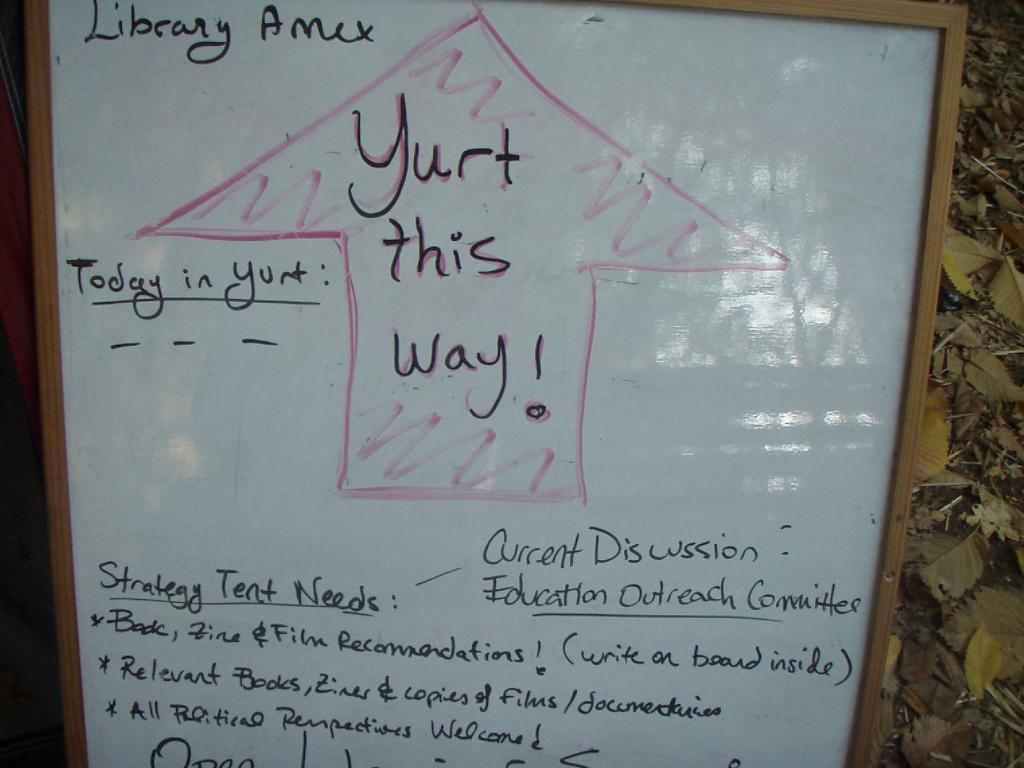<image>
Present a compact description of the photo's key features. A Library Amex whiteboard with a guide to Yurt. 